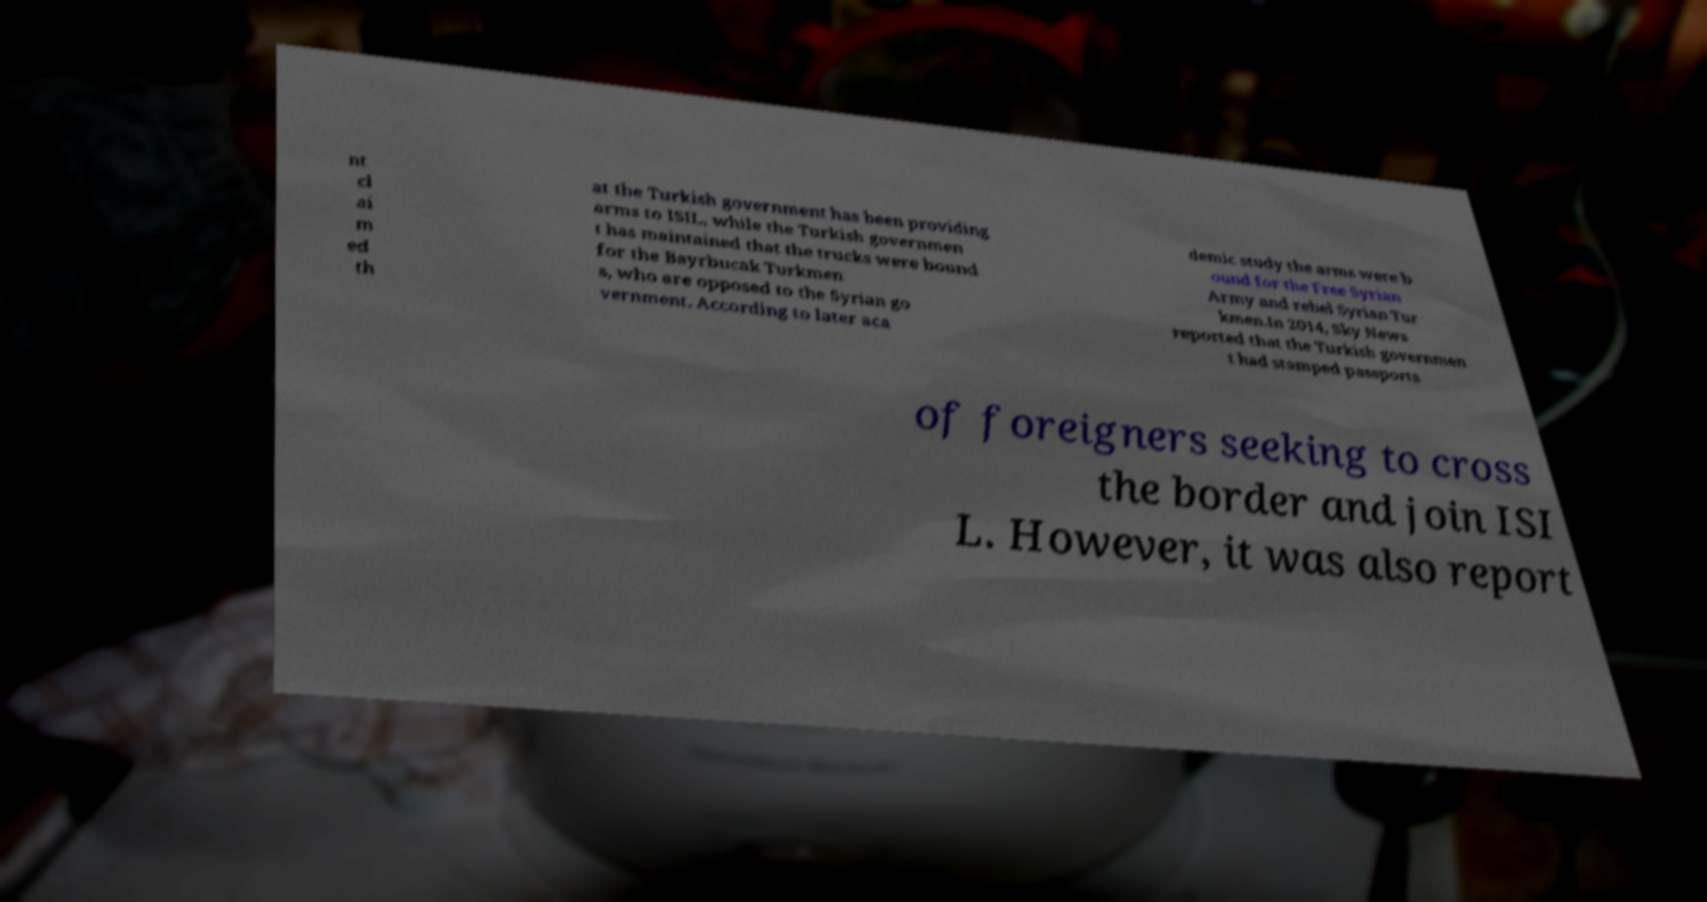Please read and relay the text visible in this image. What does it say? nt cl ai m ed th at the Turkish government has been providing arms to ISIL, while the Turkish governmen t has maintained that the trucks were bound for the Bayrbucak Turkmen s, who are opposed to the Syrian go vernment. According to later aca demic study the arms were b ound for the Free Syrian Army and rebel Syrian Tur kmen.In 2014, Sky News reported that the Turkish governmen t had stamped passports of foreigners seeking to cross the border and join ISI L. However, it was also report 